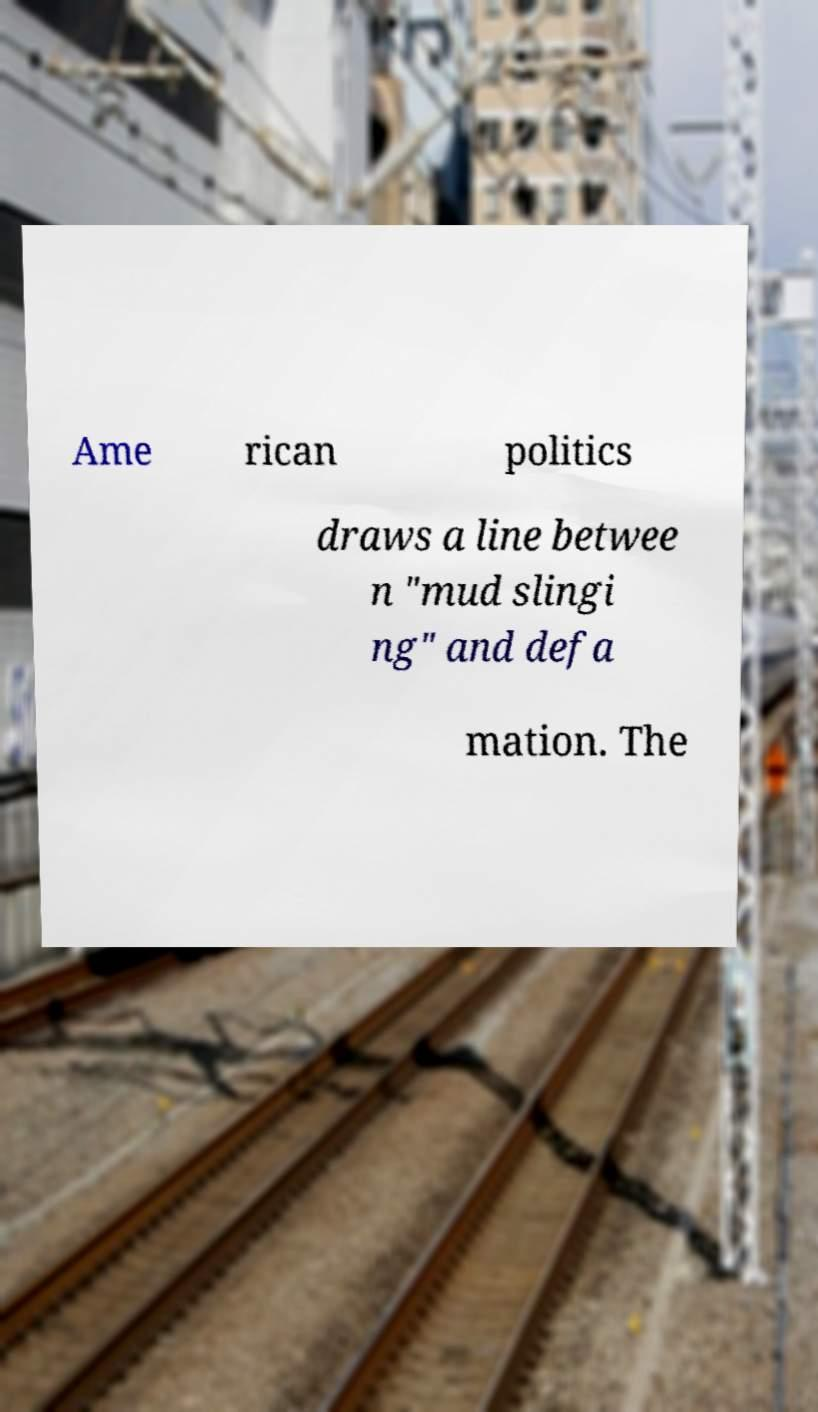Can you accurately transcribe the text from the provided image for me? Ame rican politics draws a line betwee n "mud slingi ng" and defa mation. The 